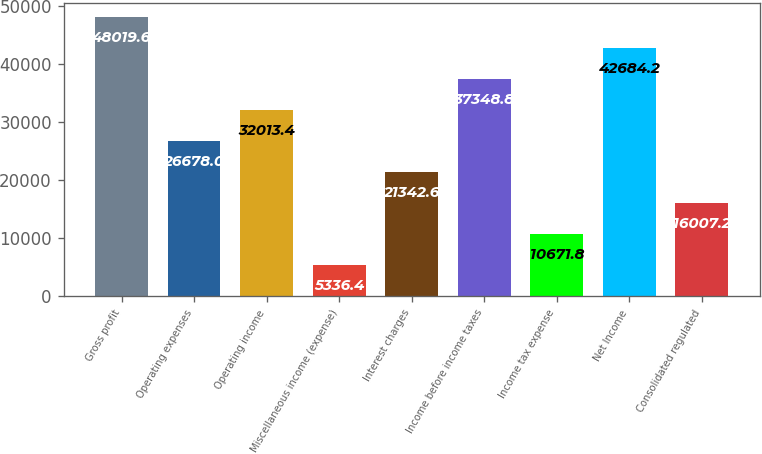Convert chart. <chart><loc_0><loc_0><loc_500><loc_500><bar_chart><fcel>Gross profit<fcel>Operating expenses<fcel>Operating income<fcel>Miscellaneous income (expense)<fcel>Interest charges<fcel>Income before income taxes<fcel>Income tax expense<fcel>Net Income<fcel>Consolidated regulated<nl><fcel>48019.6<fcel>26678<fcel>32013.4<fcel>5336.4<fcel>21342.6<fcel>37348.8<fcel>10671.8<fcel>42684.2<fcel>16007.2<nl></chart> 